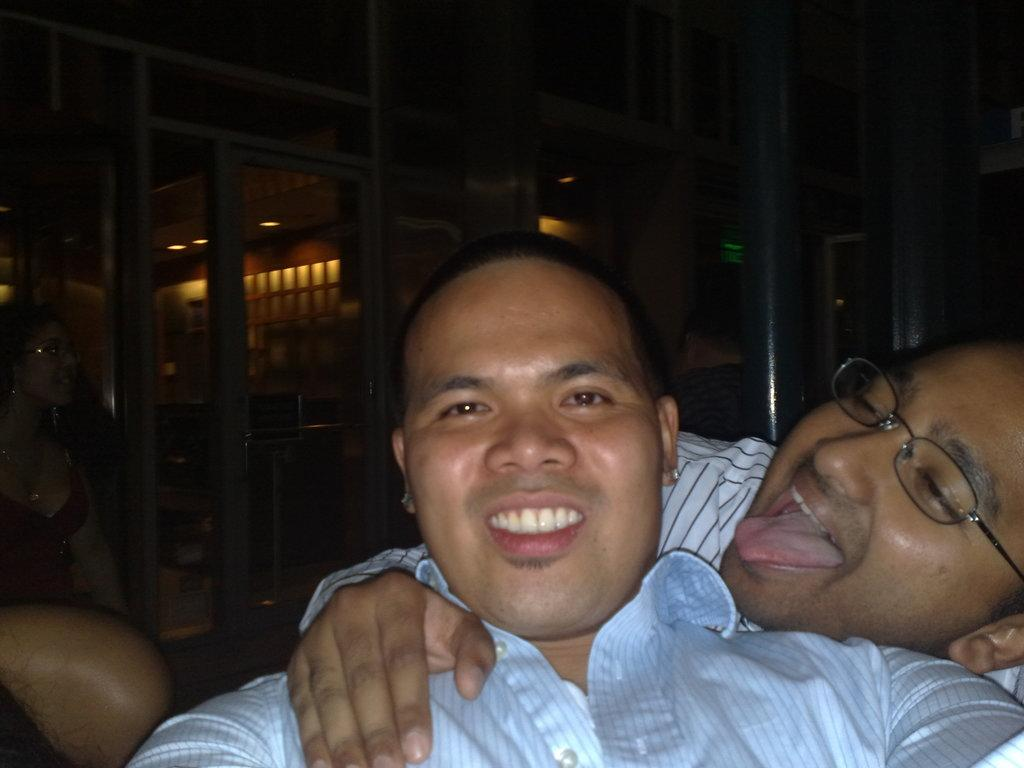Who or what can be seen in the image? There are people in the image. What is visible in the background of the image? There is a wall in the background of the image. Are there any additional features on the wall in the background? Yes, there are lights on the wall in the background. What type of engine can be seen powering the people in the image? There is no engine present in the image, and the people are not being powered by any engine. 